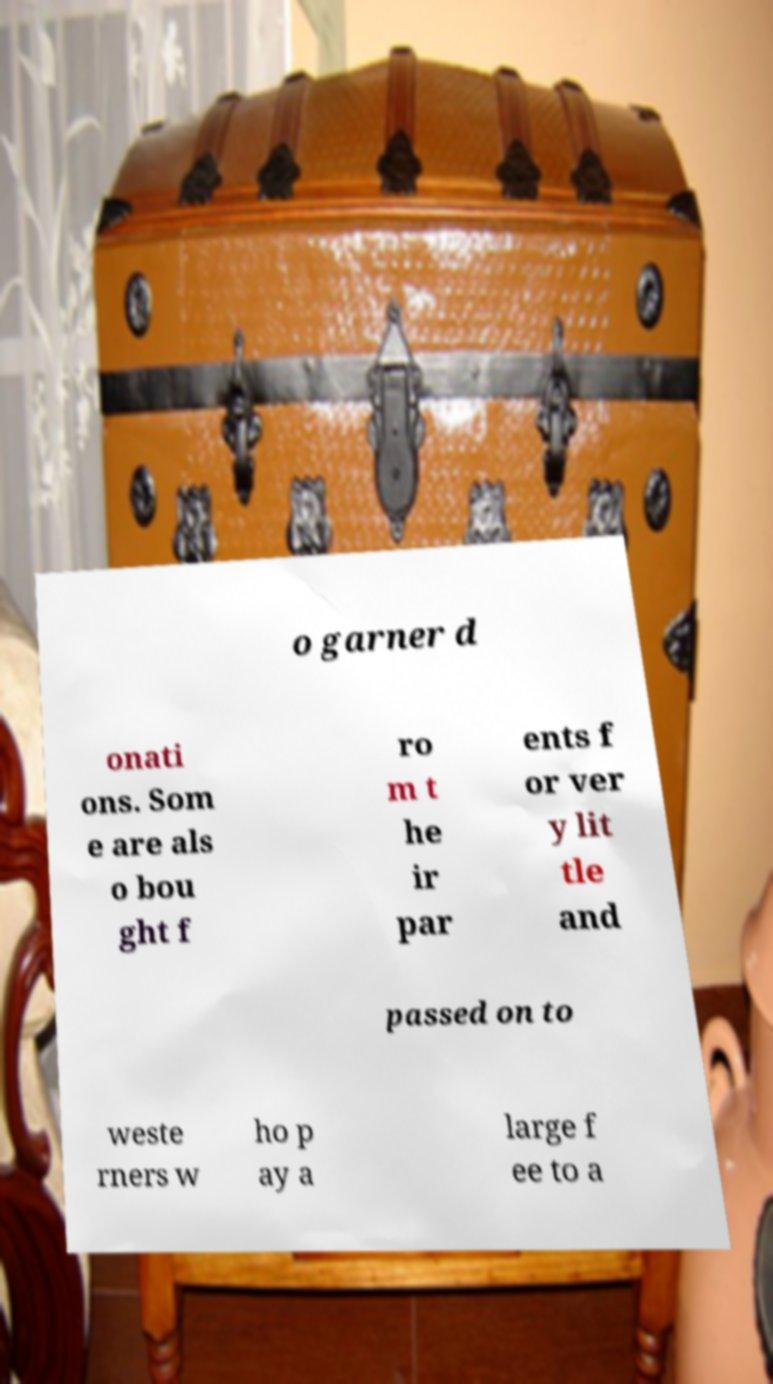Could you extract and type out the text from this image? o garner d onati ons. Som e are als o bou ght f ro m t he ir par ents f or ver y lit tle and passed on to weste rners w ho p ay a large f ee to a 